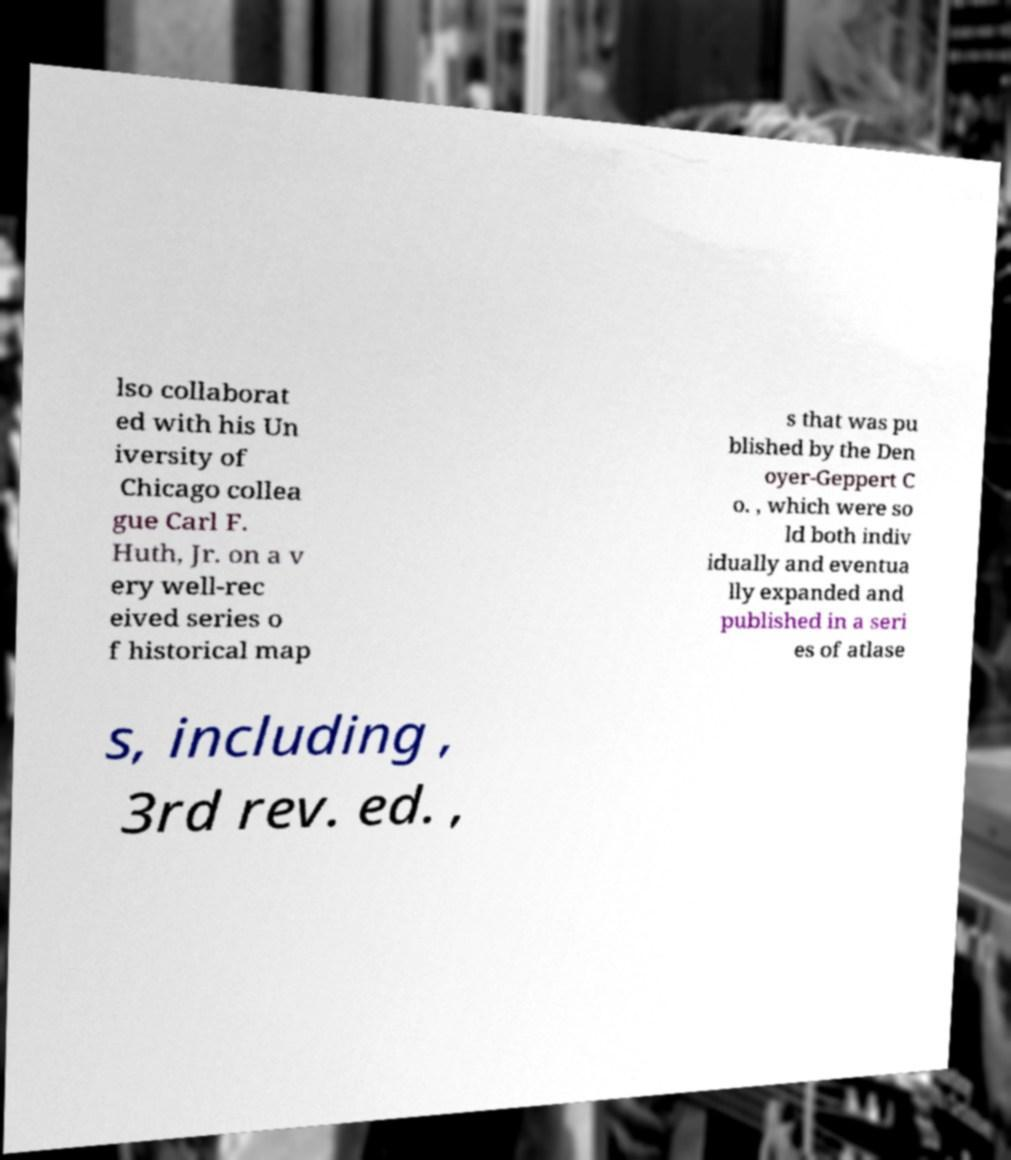Please read and relay the text visible in this image. What does it say? lso collaborat ed with his Un iversity of Chicago collea gue Carl F. Huth, Jr. on a v ery well-rec eived series o f historical map s that was pu blished by the Den oyer-Geppert C o. , which were so ld both indiv idually and eventua lly expanded and published in a seri es of atlase s, including , 3rd rev. ed. , 